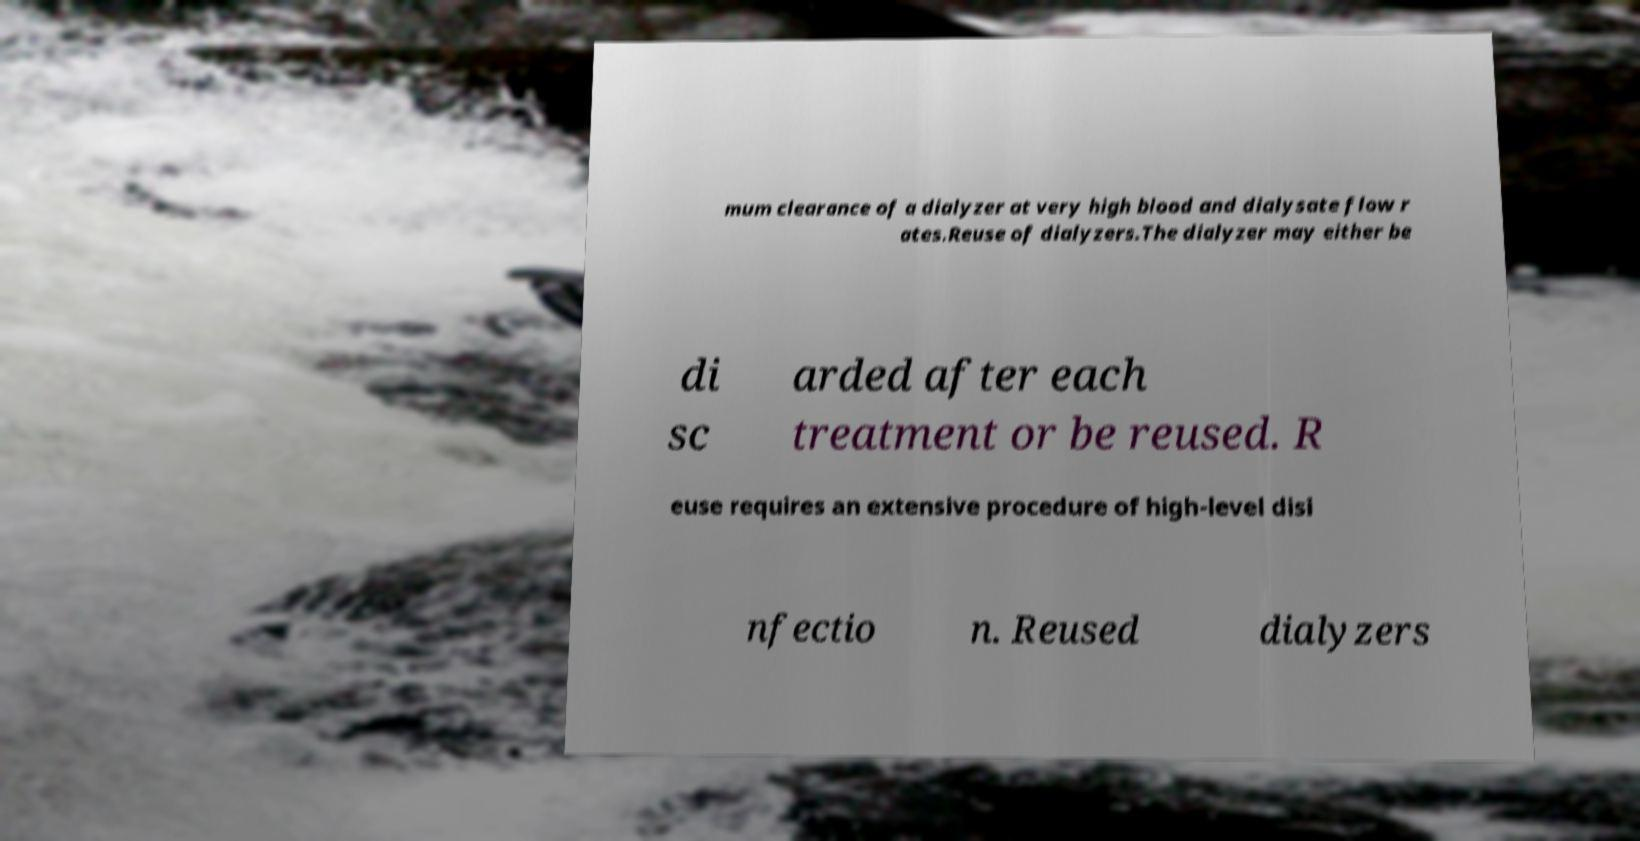Can you accurately transcribe the text from the provided image for me? mum clearance of a dialyzer at very high blood and dialysate flow r ates.Reuse of dialyzers.The dialyzer may either be di sc arded after each treatment or be reused. R euse requires an extensive procedure of high-level disi nfectio n. Reused dialyzers 